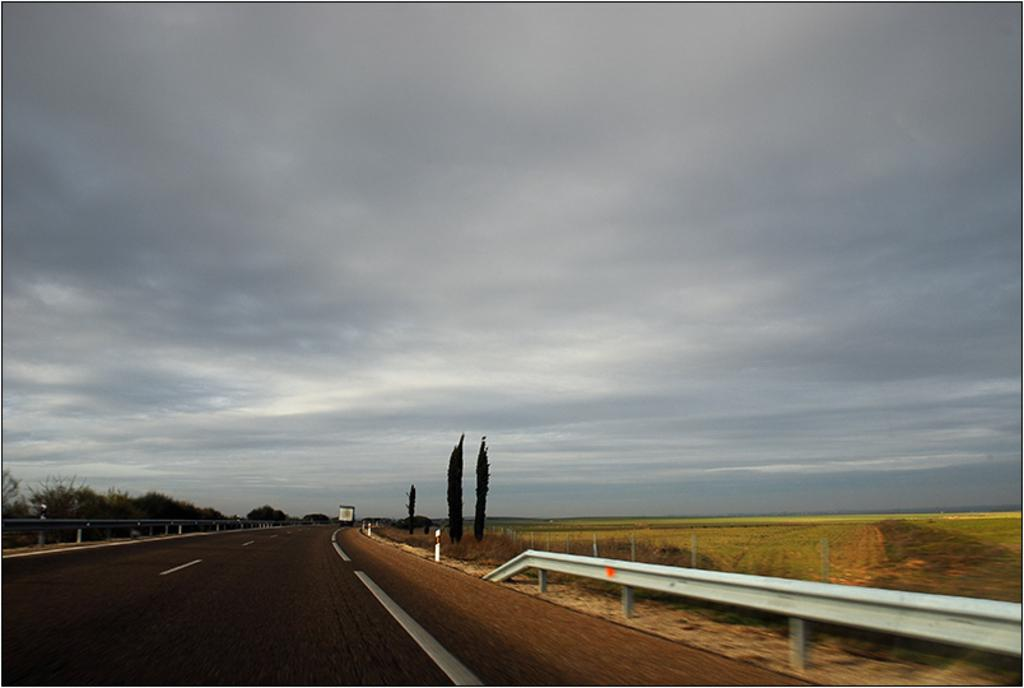What is happening on the road in the image? There is a vehicle passing on the road in the image. What can be seen on both sides of the road? There is a metal fence on either side of the road. What is visible beyond the metal fence? There are trees on the other side of the fence. What type of zipper can be seen on the trees in the image? There are no zippers present on the trees in the image. What shape is the jar that is visible in the image? There is no jar present in the image. 